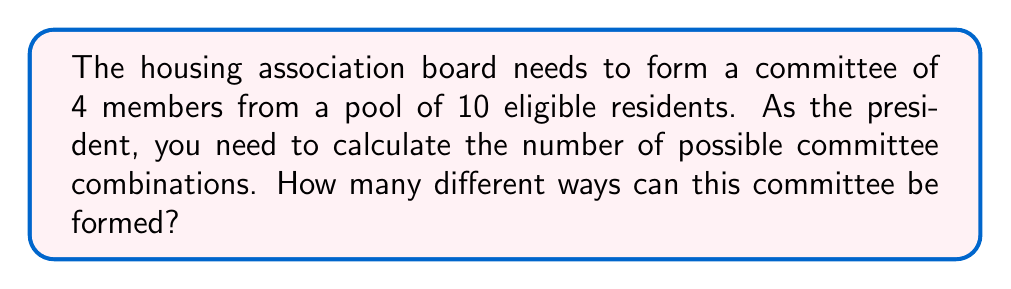Give your solution to this math problem. To solve this problem, we'll use the combination formula, as the order of selection doesn't matter (it's a committee, not a ranked list).

1) We're choosing 4 people from a group of 10.
2) This is denoted as $\binom{10}{4}$ or $C(10,4)$.
3) The formula for this combination is:

   $$\binom{n}{r} = \frac{n!}{r!(n-r)!}$$

   Where $n$ is the total number of items to choose from, and $r$ is the number of items being chosen.

4) Plugging in our values:

   $$\binom{10}{4} = \frac{10!}{4!(10-4)!} = \frac{10!}{4!6!}$$

5) Expand this:
   
   $$\frac{10 \cdot 9 \cdot 8 \cdot 7 \cdot 6!}{(4 \cdot 3 \cdot 2 \cdot 1) \cdot 6!}$$

6) The 6! cancels out in the numerator and denominator:

   $$\frac{10 \cdot 9 \cdot 8 \cdot 7}{4 \cdot 3 \cdot 2 \cdot 1}$$

7) Multiply the numerator and denominator:

   $$\frac{5040}{24} = 210$$

Therefore, there are 210 different ways to form the committee.
Answer: 210 